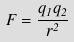Convert formula to latex. <formula><loc_0><loc_0><loc_500><loc_500>F = \frac { q _ { 1 } q _ { 2 } } { r ^ { 2 } }</formula> 